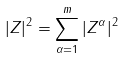Convert formula to latex. <formula><loc_0><loc_0><loc_500><loc_500>| Z | ^ { 2 } = \sum _ { \alpha = 1 } ^ { m } | Z ^ { \alpha } | ^ { 2 }</formula> 